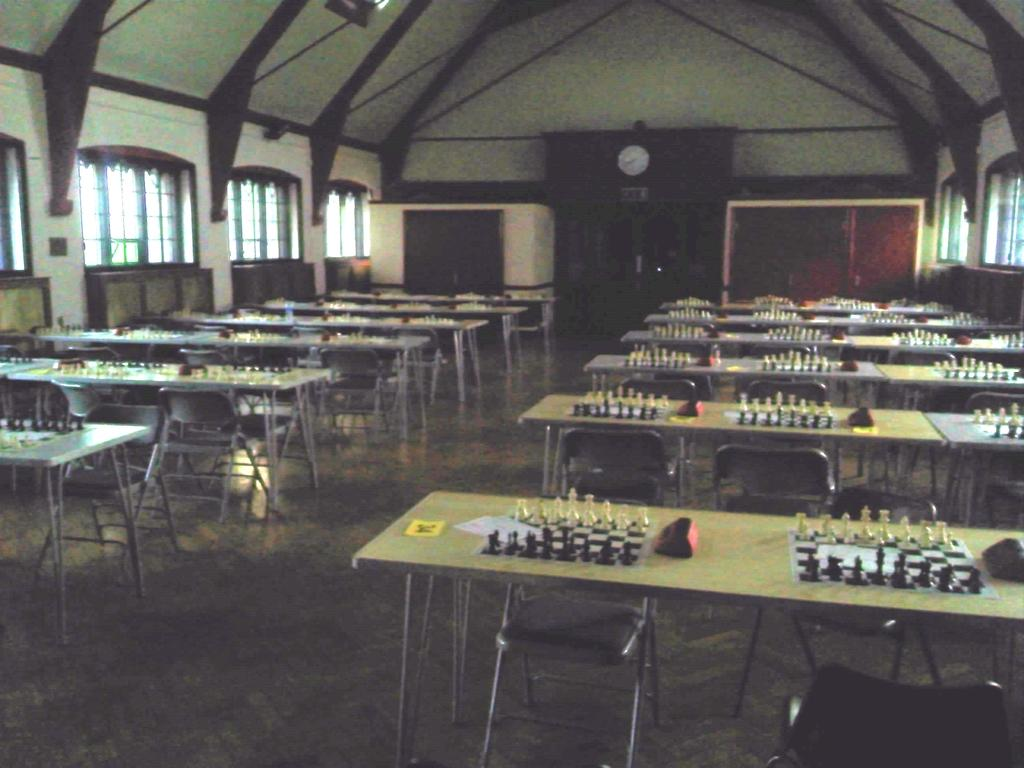What game is being played in the image? Chess is being played in the image, as evidenced by the presence of chess pieces and a chess board. What is the setting for the game? The game is being played on tables, chairs, and the floor, with objects scattered around. What can be seen in the background of the image? In the background of the image, there are windows, a wall, and a clock. How many pages are there in the book that the chess pieces are reading in the image? There is no book or reading material present in the image; the chess pieces are focused on the game. How many legs does the chess board have in the image? The chess board is a flat surface and does not have legs. 